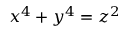<formula> <loc_0><loc_0><loc_500><loc_500>x ^ { 4 } + y ^ { 4 } = z ^ { 2 }</formula> 